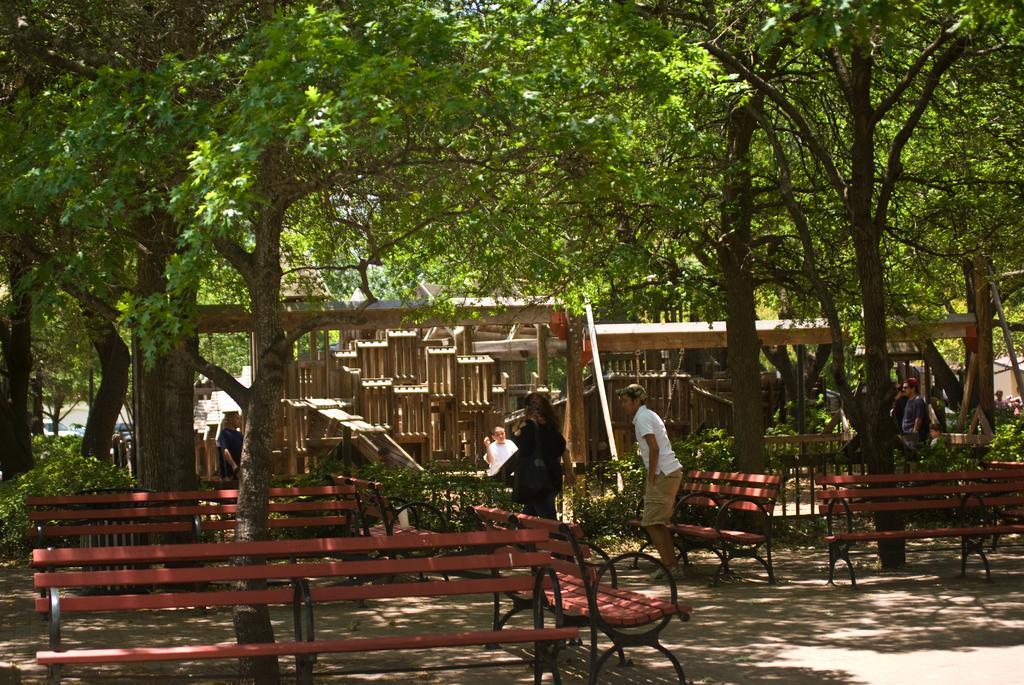In one or two sentences, can you explain what this image depicts? In this picture, it seems like a garden, here we have so many benches present. Here we have a man standing and woman moving. Also it seems like wooden art. 